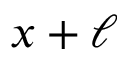Convert formula to latex. <formula><loc_0><loc_0><loc_500><loc_500>x + \ell</formula> 